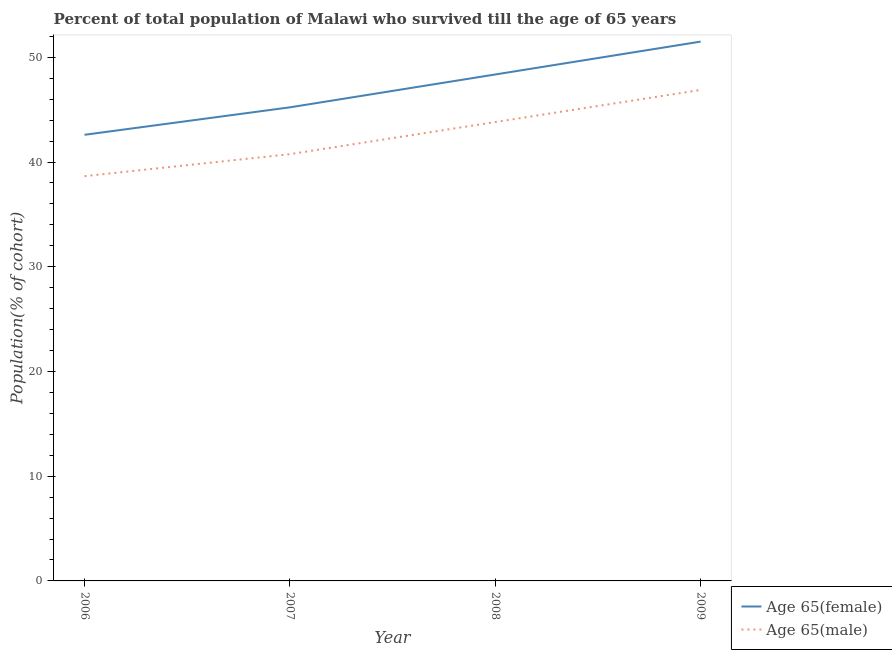How many different coloured lines are there?
Provide a succinct answer. 2. What is the percentage of male population who survived till age of 65 in 2006?
Provide a succinct answer. 38.65. Across all years, what is the maximum percentage of male population who survived till age of 65?
Offer a very short reply. 46.89. Across all years, what is the minimum percentage of female population who survived till age of 65?
Your answer should be compact. 42.6. What is the total percentage of male population who survived till age of 65 in the graph?
Keep it short and to the point. 170.11. What is the difference between the percentage of male population who survived till age of 65 in 2007 and that in 2009?
Keep it short and to the point. -6.13. What is the difference between the percentage of female population who survived till age of 65 in 2006 and the percentage of male population who survived till age of 65 in 2009?
Provide a succinct answer. -4.28. What is the average percentage of female population who survived till age of 65 per year?
Offer a terse response. 46.92. In the year 2007, what is the difference between the percentage of male population who survived till age of 65 and percentage of female population who survived till age of 65?
Your response must be concise. -4.47. What is the ratio of the percentage of male population who survived till age of 65 in 2008 to that in 2009?
Ensure brevity in your answer.  0.93. Is the percentage of female population who survived till age of 65 in 2007 less than that in 2009?
Offer a terse response. Yes. Is the difference between the percentage of male population who survived till age of 65 in 2006 and 2009 greater than the difference between the percentage of female population who survived till age of 65 in 2006 and 2009?
Your answer should be very brief. Yes. What is the difference between the highest and the second highest percentage of female population who survived till age of 65?
Offer a very short reply. 3.14. What is the difference between the highest and the lowest percentage of male population who survived till age of 65?
Make the answer very short. 8.23. Is the percentage of male population who survived till age of 65 strictly greater than the percentage of female population who survived till age of 65 over the years?
Keep it short and to the point. No. Is the percentage of male population who survived till age of 65 strictly less than the percentage of female population who survived till age of 65 over the years?
Provide a succinct answer. Yes. How many lines are there?
Your answer should be compact. 2. What is the difference between two consecutive major ticks on the Y-axis?
Keep it short and to the point. 10. Does the graph contain any zero values?
Keep it short and to the point. No. Where does the legend appear in the graph?
Provide a short and direct response. Bottom right. How many legend labels are there?
Your response must be concise. 2. What is the title of the graph?
Your answer should be very brief. Percent of total population of Malawi who survived till the age of 65 years. Does "Gasoline" appear as one of the legend labels in the graph?
Your answer should be compact. No. What is the label or title of the Y-axis?
Provide a short and direct response. Population(% of cohort). What is the Population(% of cohort) in Age 65(female) in 2006?
Make the answer very short. 42.6. What is the Population(% of cohort) in Age 65(male) in 2006?
Make the answer very short. 38.65. What is the Population(% of cohort) in Age 65(female) in 2007?
Ensure brevity in your answer.  45.23. What is the Population(% of cohort) in Age 65(male) in 2007?
Your response must be concise. 40.75. What is the Population(% of cohort) of Age 65(female) in 2008?
Provide a short and direct response. 48.36. What is the Population(% of cohort) in Age 65(male) in 2008?
Your answer should be very brief. 43.82. What is the Population(% of cohort) of Age 65(female) in 2009?
Provide a short and direct response. 51.5. What is the Population(% of cohort) of Age 65(male) in 2009?
Ensure brevity in your answer.  46.89. Across all years, what is the maximum Population(% of cohort) in Age 65(female)?
Provide a short and direct response. 51.5. Across all years, what is the maximum Population(% of cohort) in Age 65(male)?
Provide a short and direct response. 46.89. Across all years, what is the minimum Population(% of cohort) in Age 65(female)?
Keep it short and to the point. 42.6. Across all years, what is the minimum Population(% of cohort) of Age 65(male)?
Give a very brief answer. 38.65. What is the total Population(% of cohort) in Age 65(female) in the graph?
Offer a terse response. 187.7. What is the total Population(% of cohort) in Age 65(male) in the graph?
Provide a short and direct response. 170.11. What is the difference between the Population(% of cohort) of Age 65(female) in 2006 and that in 2007?
Keep it short and to the point. -2.62. What is the difference between the Population(% of cohort) in Age 65(male) in 2006 and that in 2007?
Offer a terse response. -2.1. What is the difference between the Population(% of cohort) of Age 65(female) in 2006 and that in 2008?
Your response must be concise. -5.76. What is the difference between the Population(% of cohort) in Age 65(male) in 2006 and that in 2008?
Ensure brevity in your answer.  -5.17. What is the difference between the Population(% of cohort) in Age 65(female) in 2006 and that in 2009?
Give a very brief answer. -8.9. What is the difference between the Population(% of cohort) of Age 65(male) in 2006 and that in 2009?
Your answer should be compact. -8.23. What is the difference between the Population(% of cohort) of Age 65(female) in 2007 and that in 2008?
Ensure brevity in your answer.  -3.14. What is the difference between the Population(% of cohort) in Age 65(male) in 2007 and that in 2008?
Ensure brevity in your answer.  -3.07. What is the difference between the Population(% of cohort) of Age 65(female) in 2007 and that in 2009?
Your answer should be very brief. -6.28. What is the difference between the Population(% of cohort) in Age 65(male) in 2007 and that in 2009?
Your answer should be very brief. -6.13. What is the difference between the Population(% of cohort) of Age 65(female) in 2008 and that in 2009?
Provide a short and direct response. -3.14. What is the difference between the Population(% of cohort) in Age 65(male) in 2008 and that in 2009?
Provide a short and direct response. -3.07. What is the difference between the Population(% of cohort) in Age 65(female) in 2006 and the Population(% of cohort) in Age 65(male) in 2007?
Provide a succinct answer. 1.85. What is the difference between the Population(% of cohort) in Age 65(female) in 2006 and the Population(% of cohort) in Age 65(male) in 2008?
Give a very brief answer. -1.22. What is the difference between the Population(% of cohort) of Age 65(female) in 2006 and the Population(% of cohort) of Age 65(male) in 2009?
Keep it short and to the point. -4.28. What is the difference between the Population(% of cohort) of Age 65(female) in 2007 and the Population(% of cohort) of Age 65(male) in 2008?
Offer a very short reply. 1.41. What is the difference between the Population(% of cohort) in Age 65(female) in 2007 and the Population(% of cohort) in Age 65(male) in 2009?
Give a very brief answer. -1.66. What is the difference between the Population(% of cohort) of Age 65(female) in 2008 and the Population(% of cohort) of Age 65(male) in 2009?
Keep it short and to the point. 1.48. What is the average Population(% of cohort) of Age 65(female) per year?
Keep it short and to the point. 46.92. What is the average Population(% of cohort) in Age 65(male) per year?
Make the answer very short. 42.53. In the year 2006, what is the difference between the Population(% of cohort) of Age 65(female) and Population(% of cohort) of Age 65(male)?
Ensure brevity in your answer.  3.95. In the year 2007, what is the difference between the Population(% of cohort) in Age 65(female) and Population(% of cohort) in Age 65(male)?
Keep it short and to the point. 4.47. In the year 2008, what is the difference between the Population(% of cohort) of Age 65(female) and Population(% of cohort) of Age 65(male)?
Your answer should be compact. 4.54. In the year 2009, what is the difference between the Population(% of cohort) of Age 65(female) and Population(% of cohort) of Age 65(male)?
Your answer should be very brief. 4.62. What is the ratio of the Population(% of cohort) in Age 65(female) in 2006 to that in 2007?
Provide a short and direct response. 0.94. What is the ratio of the Population(% of cohort) in Age 65(male) in 2006 to that in 2007?
Keep it short and to the point. 0.95. What is the ratio of the Population(% of cohort) in Age 65(female) in 2006 to that in 2008?
Provide a short and direct response. 0.88. What is the ratio of the Population(% of cohort) in Age 65(male) in 2006 to that in 2008?
Offer a terse response. 0.88. What is the ratio of the Population(% of cohort) of Age 65(female) in 2006 to that in 2009?
Your answer should be compact. 0.83. What is the ratio of the Population(% of cohort) of Age 65(male) in 2006 to that in 2009?
Your answer should be compact. 0.82. What is the ratio of the Population(% of cohort) in Age 65(female) in 2007 to that in 2008?
Offer a very short reply. 0.94. What is the ratio of the Population(% of cohort) in Age 65(male) in 2007 to that in 2008?
Your answer should be very brief. 0.93. What is the ratio of the Population(% of cohort) in Age 65(female) in 2007 to that in 2009?
Your answer should be compact. 0.88. What is the ratio of the Population(% of cohort) of Age 65(male) in 2007 to that in 2009?
Ensure brevity in your answer.  0.87. What is the ratio of the Population(% of cohort) in Age 65(female) in 2008 to that in 2009?
Your answer should be very brief. 0.94. What is the ratio of the Population(% of cohort) in Age 65(male) in 2008 to that in 2009?
Ensure brevity in your answer.  0.93. What is the difference between the highest and the second highest Population(% of cohort) of Age 65(female)?
Offer a very short reply. 3.14. What is the difference between the highest and the second highest Population(% of cohort) in Age 65(male)?
Make the answer very short. 3.07. What is the difference between the highest and the lowest Population(% of cohort) in Age 65(female)?
Offer a terse response. 8.9. What is the difference between the highest and the lowest Population(% of cohort) in Age 65(male)?
Provide a succinct answer. 8.23. 